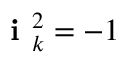<formula> <loc_0><loc_0><loc_500><loc_500>i _ { k } ^ { 2 } = - 1</formula> 